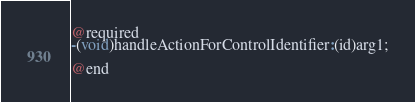<code> <loc_0><loc_0><loc_500><loc_500><_C_>@required
-(void)handleActionForControlIdentifier:(id)arg1;

@end

</code> 